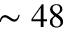Convert formula to latex. <formula><loc_0><loc_0><loc_500><loc_500>\sim 4 8</formula> 